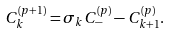<formula> <loc_0><loc_0><loc_500><loc_500>C _ { k } ^ { ( p + 1 ) } = \sigma _ { k } C _ { - } ^ { ( p ) } - C _ { k + 1 } ^ { ( p ) } .</formula> 